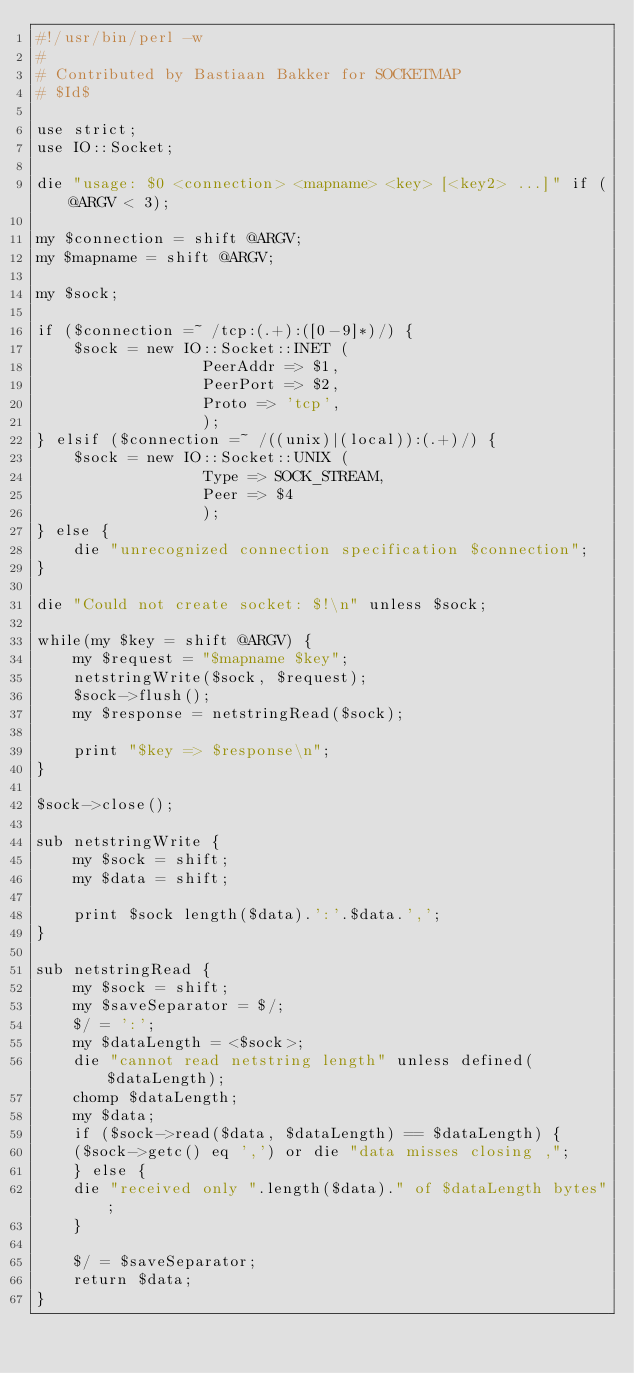<code> <loc_0><loc_0><loc_500><loc_500><_Perl_>#!/usr/bin/perl -w
#
# Contributed by Bastiaan Bakker for SOCKETMAP
# $Id$

use strict;
use IO::Socket;

die "usage: $0 <connection> <mapname> <key> [<key2> ...]" if (@ARGV < 3);

my $connection = shift @ARGV;
my $mapname = shift @ARGV;

my $sock;

if ($connection =~ /tcp:(.+):([0-9]*)/) {
    $sock = new IO::Socket::INET (
				  PeerAddr => $1,
				  PeerPort => $2,
				  Proto => 'tcp',
				  );
} elsif ($connection =~ /((unix)|(local)):(.+)/) {
    $sock = new IO::Socket::UNIX (
				  Type => SOCK_STREAM,
				  Peer => $4
				  );
} else {
    die "unrecognized connection specification $connection";
}

die "Could not create socket: $!\n" unless $sock;

while(my $key = shift @ARGV) {
    my $request = "$mapname $key";
    netstringWrite($sock, $request);
    $sock->flush();
    my $response = netstringRead($sock);

    print "$key => $response\n";
}

$sock->close();

sub netstringWrite {
    my $sock = shift;
    my $data = shift;

    print $sock length($data).':'.$data.',';
}

sub netstringRead {
    my $sock = shift;
    my $saveSeparator = $/;
    $/ = ':';
    my $dataLength = <$sock>;
    die "cannot read netstring length" unless defined($dataLength);
    chomp $dataLength;
    my $data;
    if ($sock->read($data, $dataLength) == $dataLength) {
	($sock->getc() eq ',') or die "data misses closing ,";
    } else {
	die "received only ".length($data)." of $dataLength bytes";
    }
    
    $/ = $saveSeparator;
    return $data;
}
</code> 